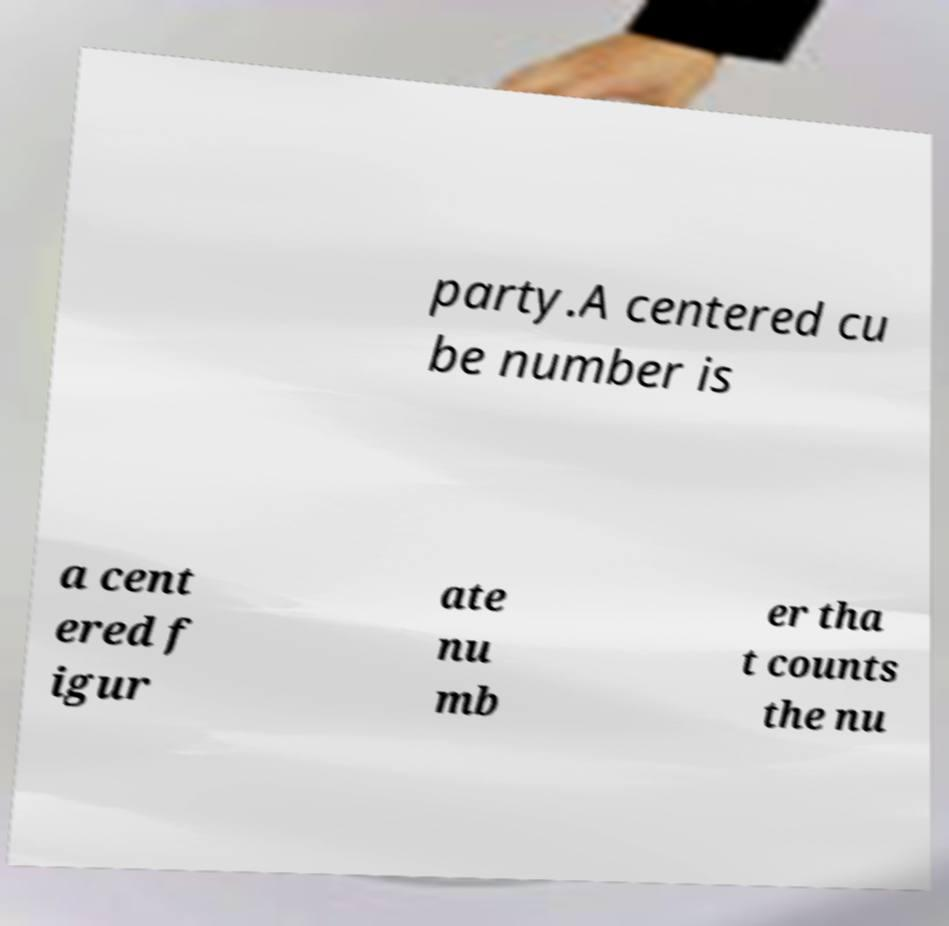Can you accurately transcribe the text from the provided image for me? party.A centered cu be number is a cent ered f igur ate nu mb er tha t counts the nu 